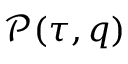<formula> <loc_0><loc_0><loc_500><loc_500>\mathcal { P } ( \tau , q )</formula> 